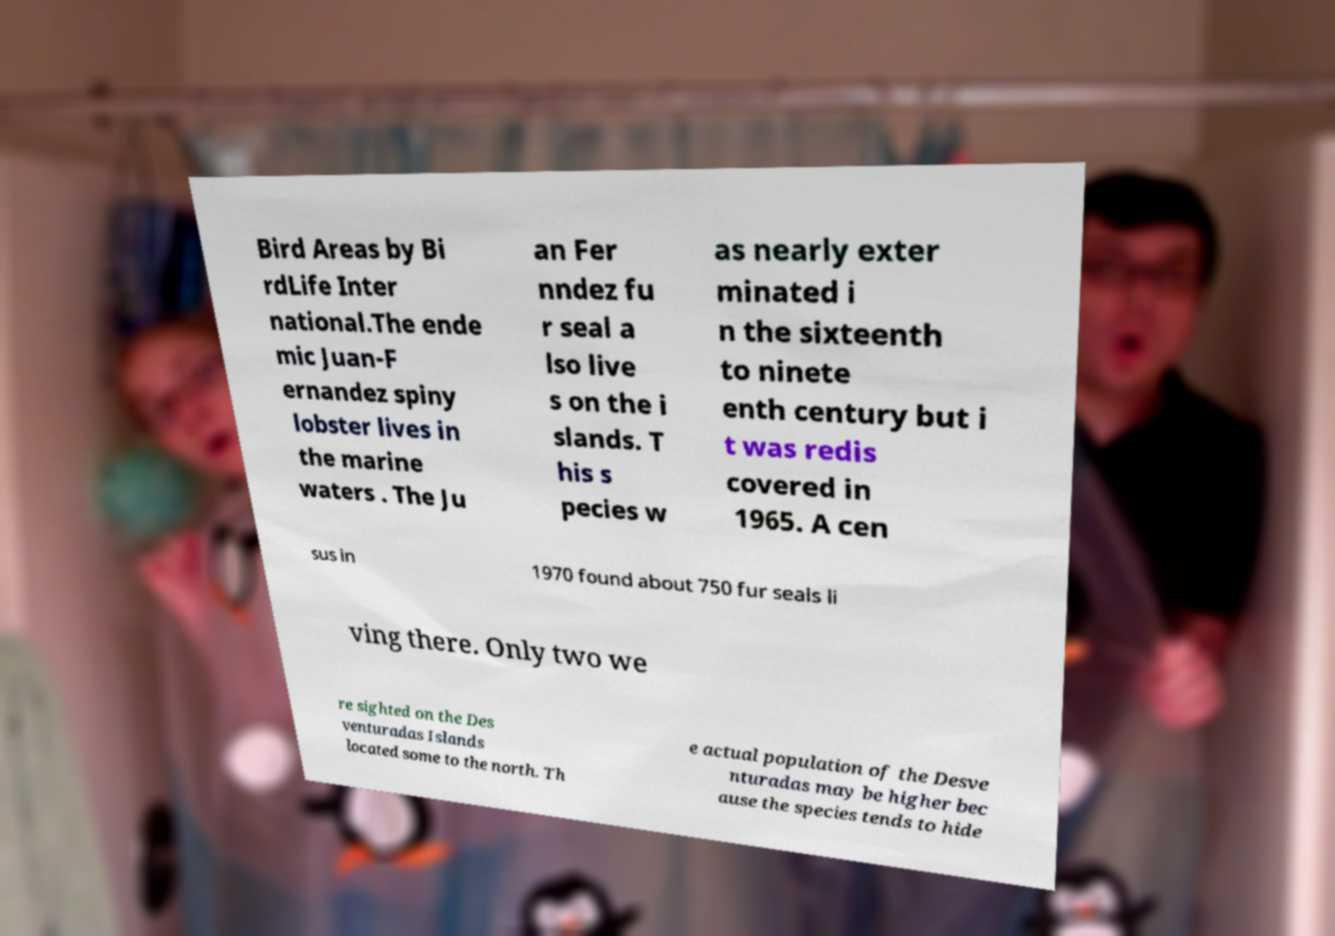What messages or text are displayed in this image? I need them in a readable, typed format. Bird Areas by Bi rdLife Inter national.The ende mic Juan-F ernandez spiny lobster lives in the marine waters . The Ju an Fer nndez fu r seal a lso live s on the i slands. T his s pecies w as nearly exter minated i n the sixteenth to ninete enth century but i t was redis covered in 1965. A cen sus in 1970 found about 750 fur seals li ving there. Only two we re sighted on the Des venturadas Islands located some to the north. Th e actual population of the Desve nturadas may be higher bec ause the species tends to hide 